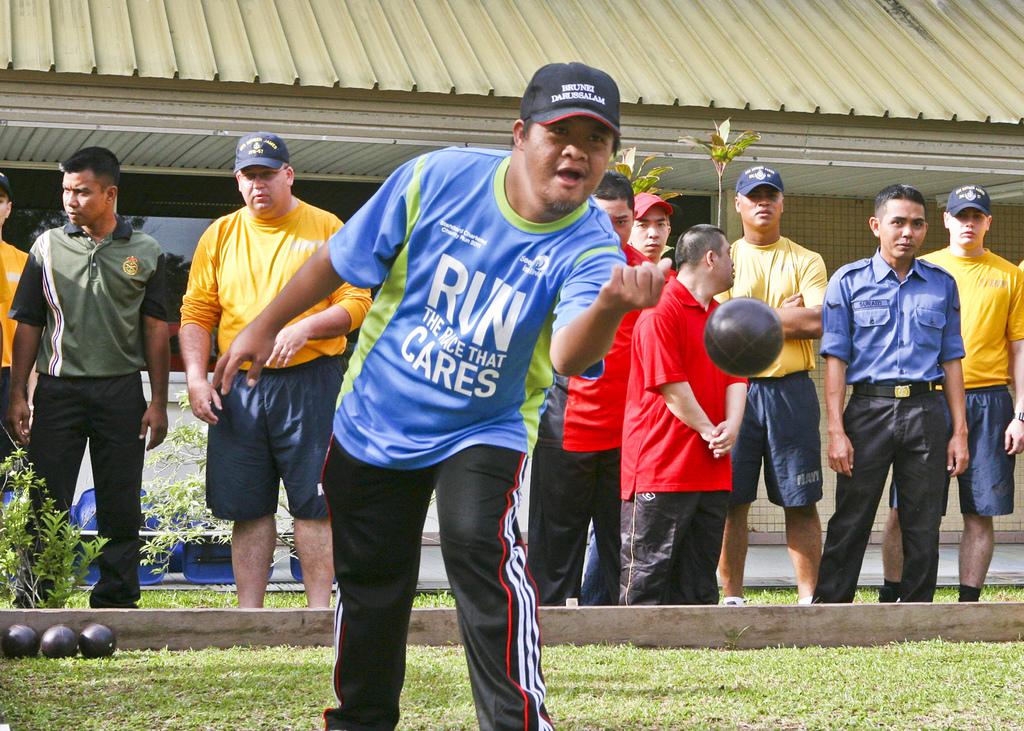According to the blue shirt, what cares?
Your answer should be very brief. The race. 